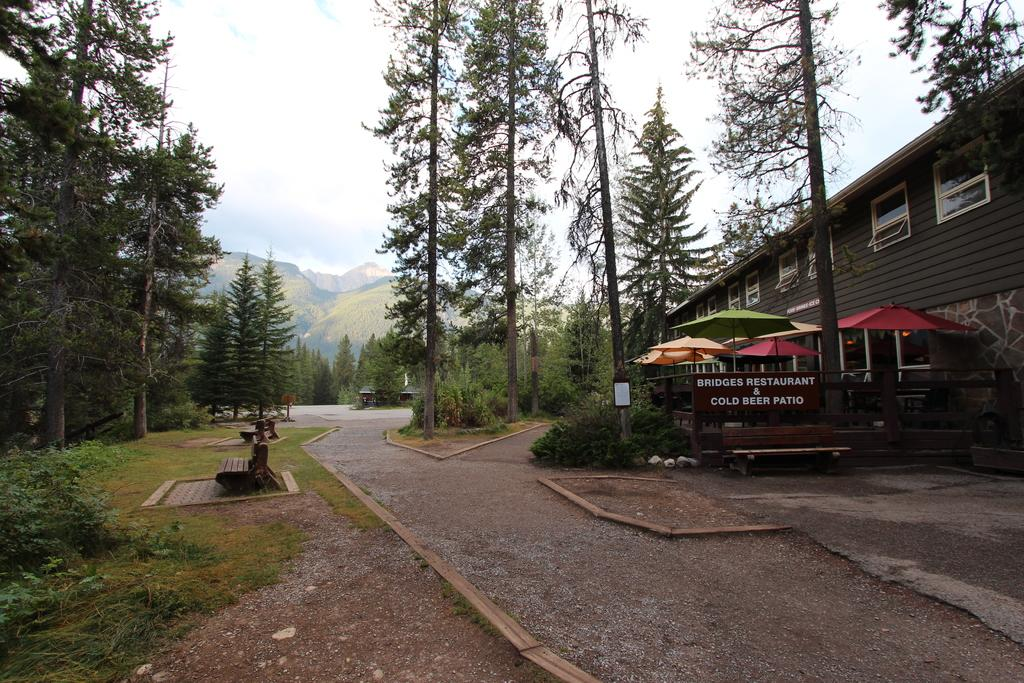What type of structure is visible in the image? There is a building with windows in the image. What natural elements can be seen in the image? There are trees, plants, mountains, and the sky visible in the image. What type of seating is available in the image? There are wooden benches in the image. Is there any textual information present in the image? Yes, there is a board with some text in the image. What nation is responsible for the construction of the building in the image? The image does not provide any information about the nation responsible for the construction of the building. How does the presence of plants in the image affect the air quality? The image does not provide any information about the air quality or the effect of the plants on it. 